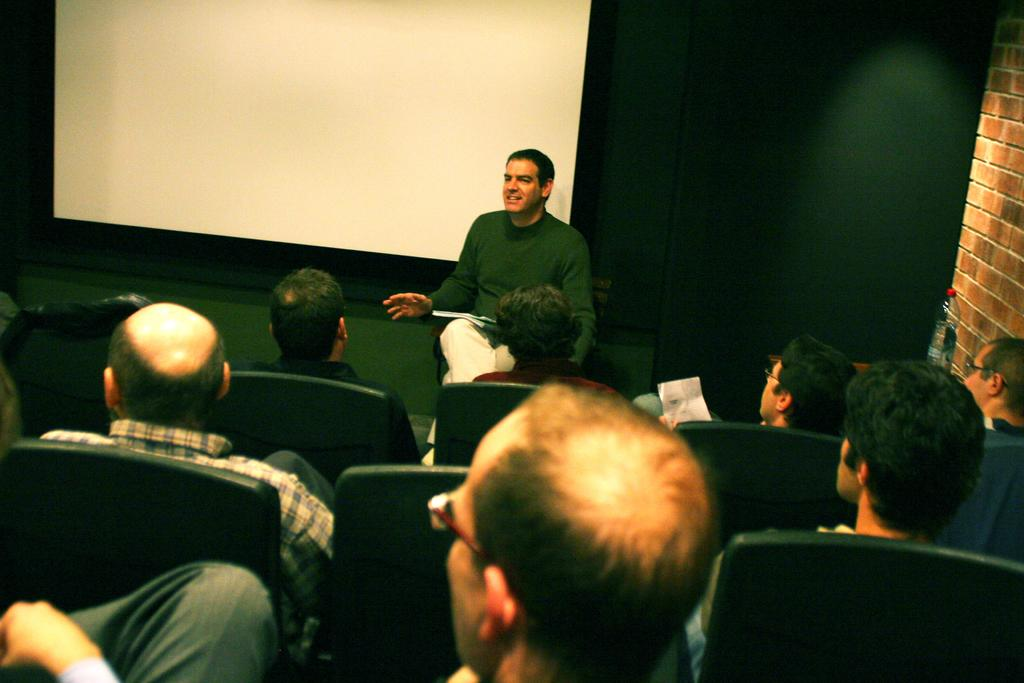What is happening with the group of people in the image? The people are sitting in the image. What can be seen on the screen that is visible in the image? The content of the screen is not specified in the facts, so we cannot answer that question. What color is the background in the image? The background color is green. How many fingers does the chicken have in its nest in the image? There is no chicken or nest present in the image. 